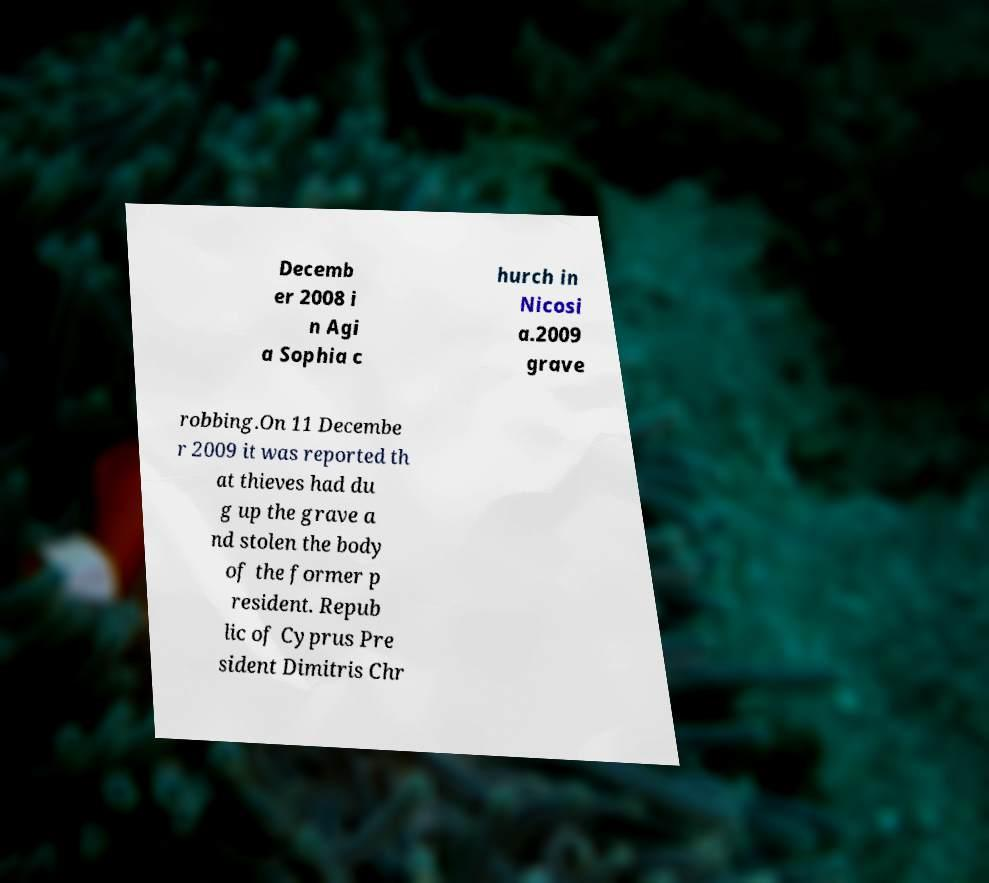Can you accurately transcribe the text from the provided image for me? Decemb er 2008 i n Agi a Sophia c hurch in Nicosi a.2009 grave robbing.On 11 Decembe r 2009 it was reported th at thieves had du g up the grave a nd stolen the body of the former p resident. Repub lic of Cyprus Pre sident Dimitris Chr 